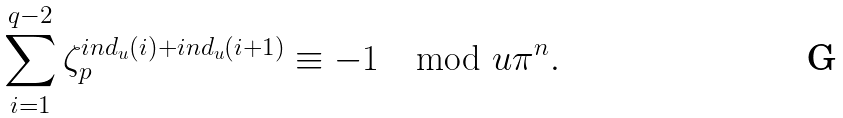<formula> <loc_0><loc_0><loc_500><loc_500>\sum _ { i = 1 } ^ { q - 2 } \zeta _ { p } ^ { i n d _ { u } ( i ) + i n d _ { u } ( i + 1 ) } \equiv - 1 \mod u \pi ^ { n } .</formula> 